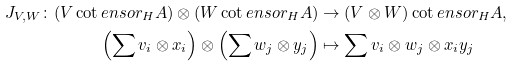<formula> <loc_0><loc_0><loc_500><loc_500>J _ { V , W } \colon ( V \cot e n s o r _ { H } A ) \otimes ( W \cot e n s o r _ { H } A ) & \to ( V \otimes W ) \cot e n s o r _ { H } A , \\ \left ( \sum v _ { i } \otimes x _ { i } \right ) \otimes \left ( \sum w _ { j } \otimes y _ { j } \right ) & \mapsto \sum v _ { i } \otimes w _ { j } \otimes x _ { i } y _ { j }</formula> 